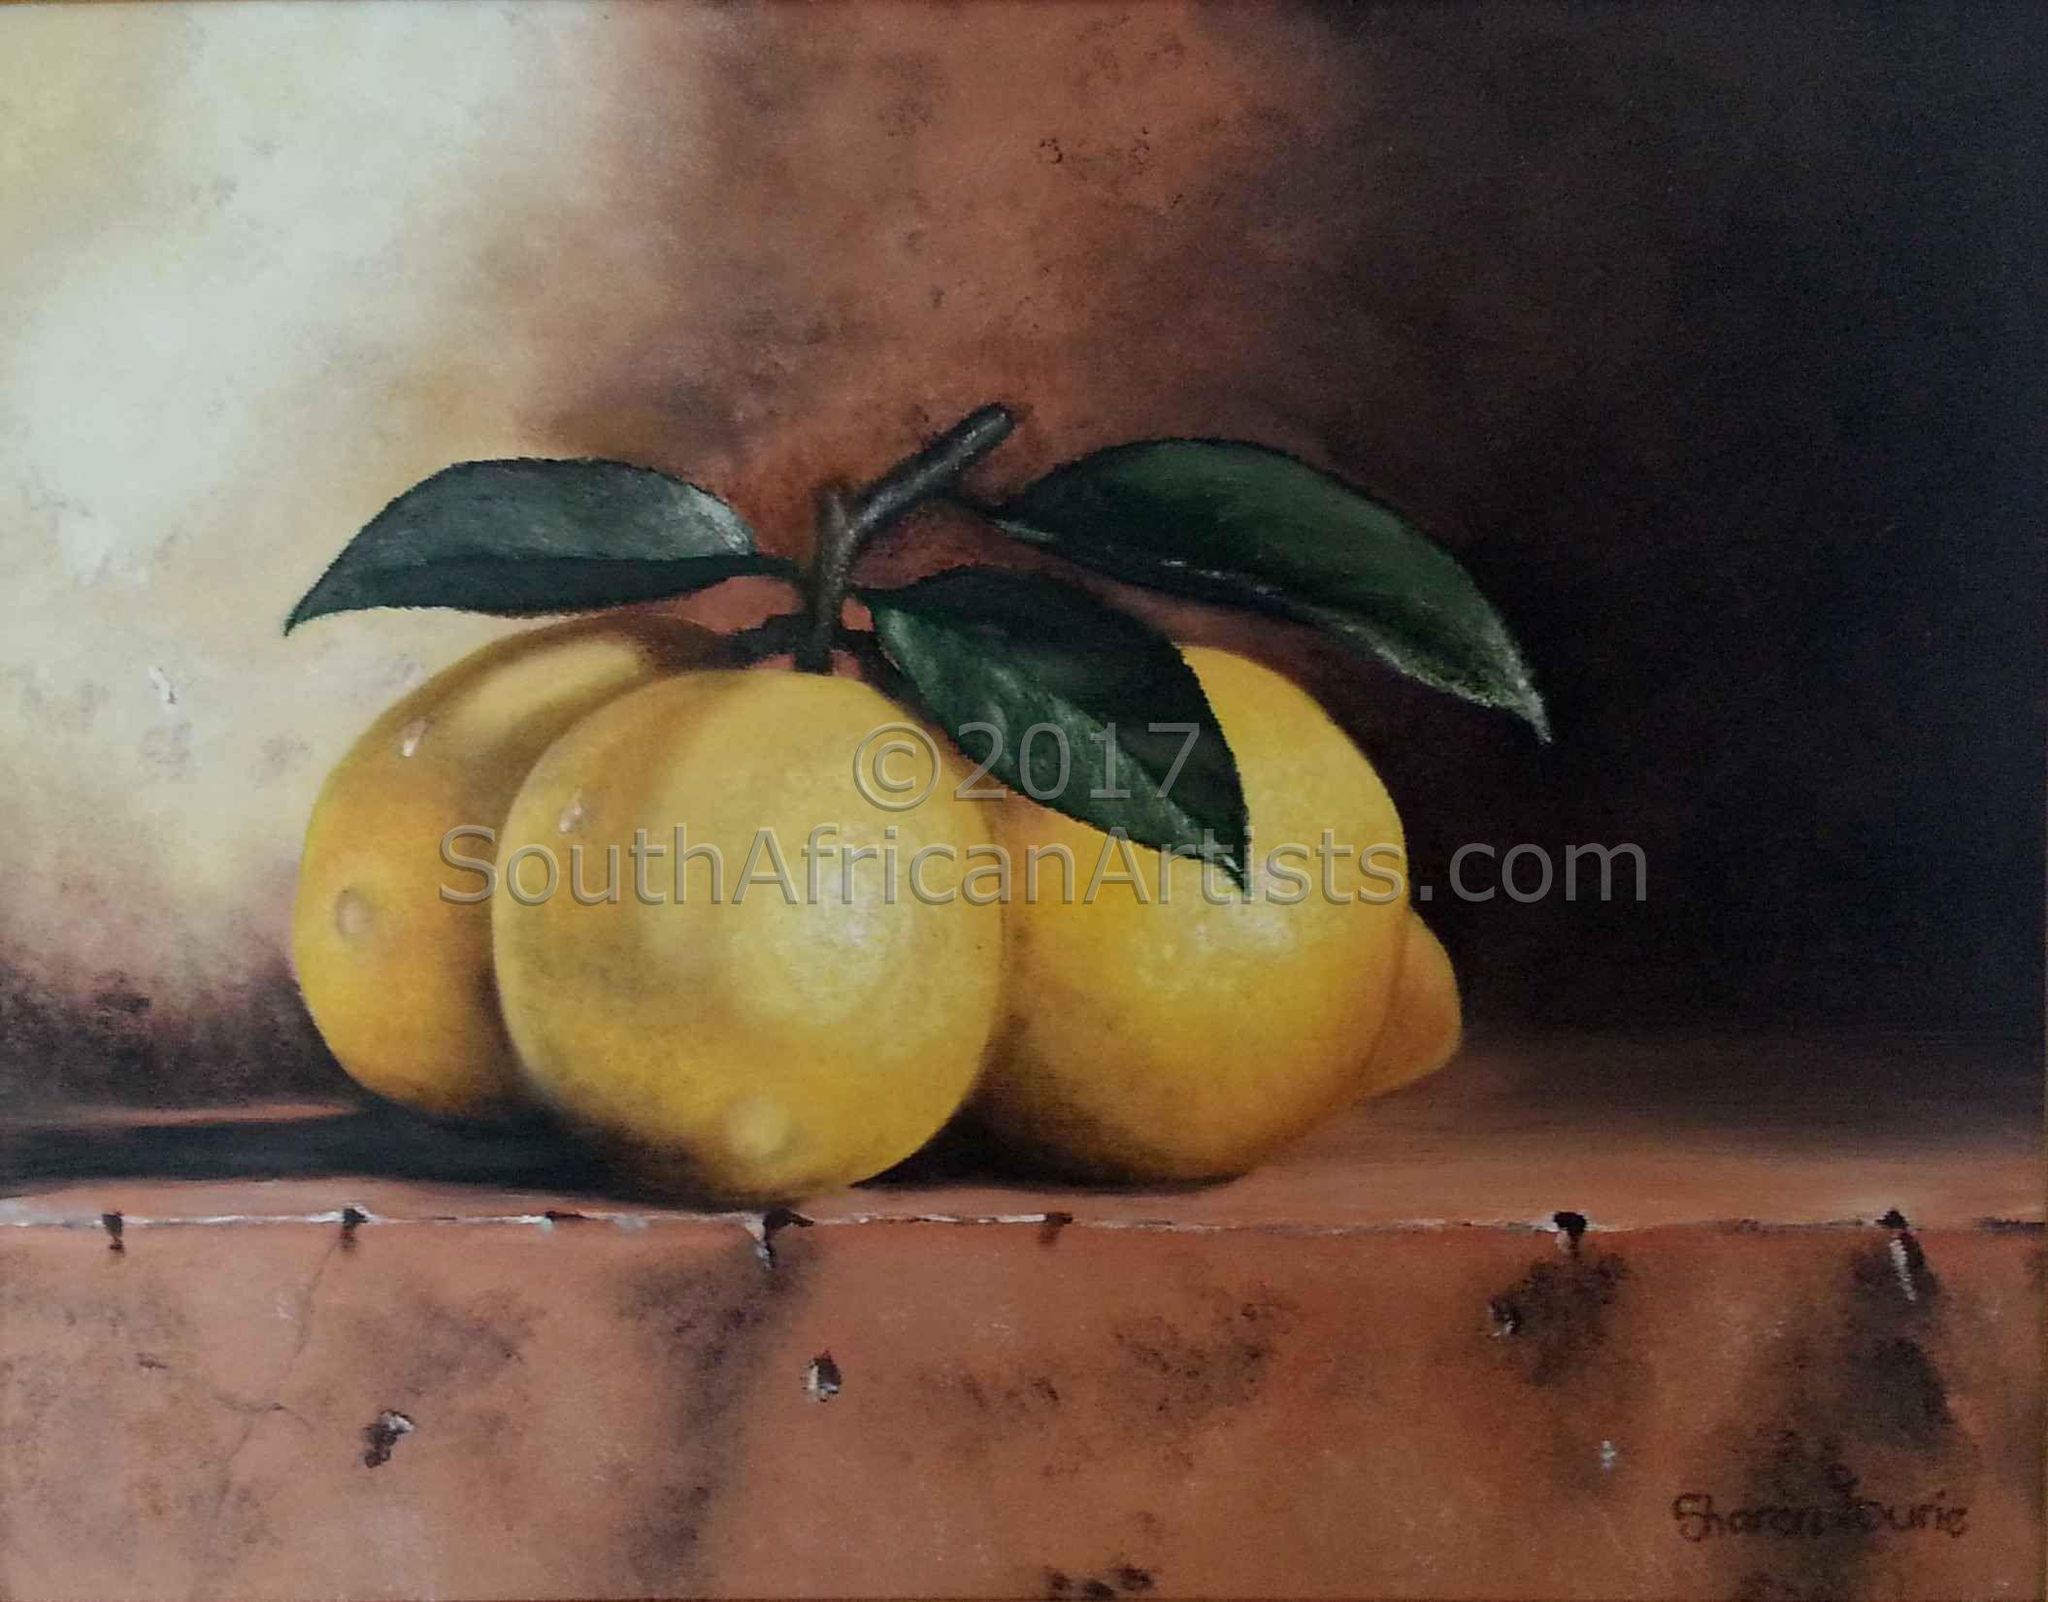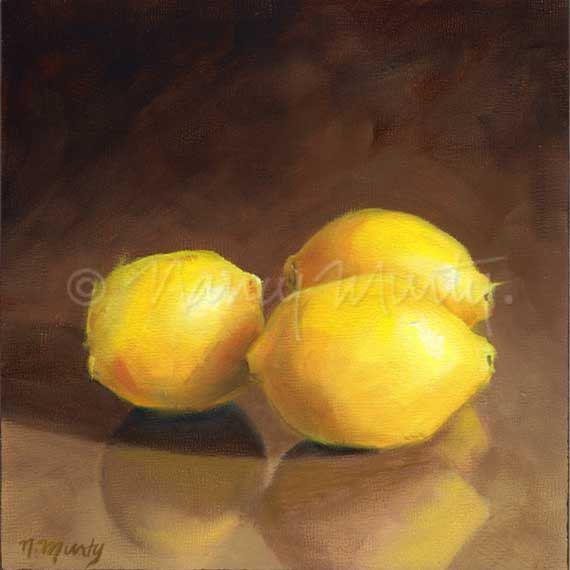The first image is the image on the left, the second image is the image on the right. Evaluate the accuracy of this statement regarding the images: "Three lemons are laying on a white and blue cloth.". Is it true? Answer yes or no. No. The first image is the image on the left, the second image is the image on the right. Examine the images to the left and right. Is the description "No image includes lemon leaves, and one image shows three whole lemons on white fabric with a blue stripe on it." accurate? Answer yes or no. No. 